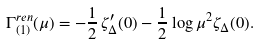<formula> <loc_0><loc_0><loc_500><loc_500>\Gamma ^ { r e n } _ { ( 1 ) } ( \mu ) = - \frac { 1 } { 2 } \, \zeta _ { \Delta } ^ { \prime } ( 0 ) - \frac { 1 } { 2 } \log \mu ^ { 2 } \zeta _ { \Delta } ( 0 ) .</formula> 